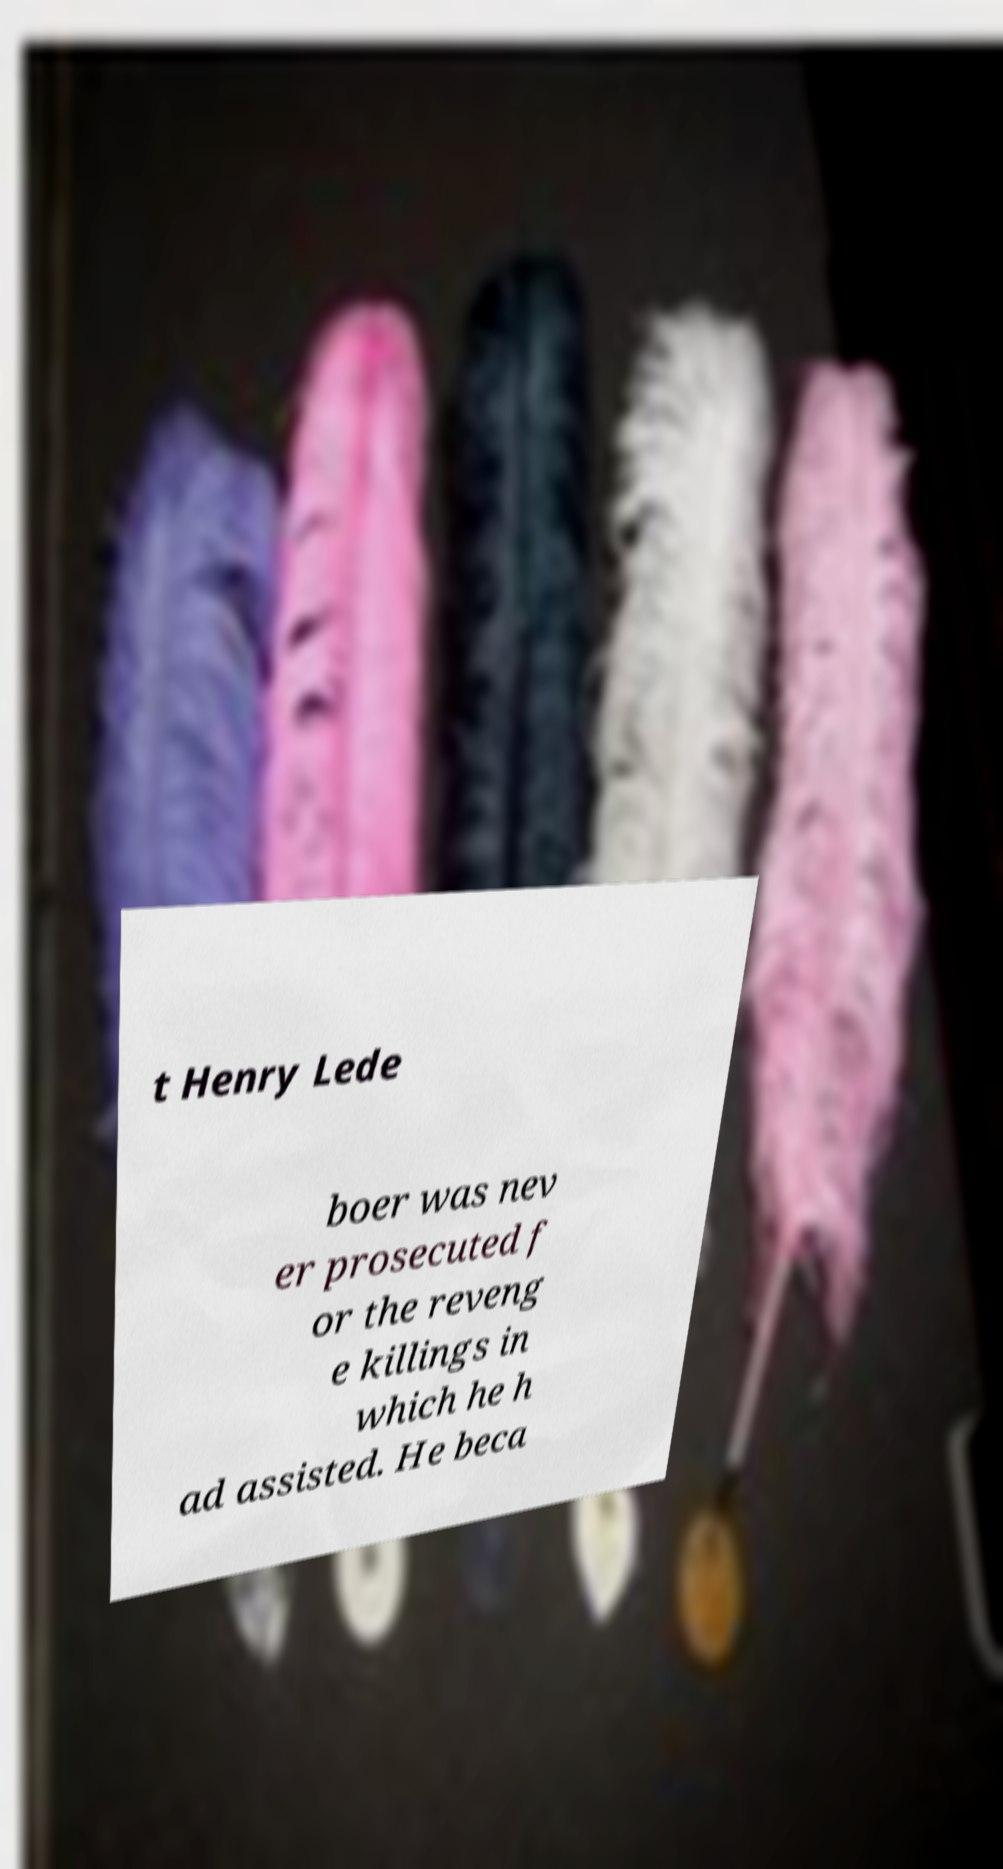I need the written content from this picture converted into text. Can you do that? t Henry Lede boer was nev er prosecuted f or the reveng e killings in which he h ad assisted. He beca 